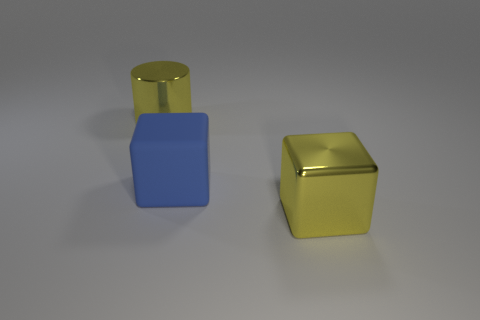Add 1 small green rubber cubes. How many objects exist? 4 Subtract all cylinders. How many objects are left? 2 Add 1 rubber objects. How many rubber objects exist? 2 Subtract 1 yellow cylinders. How many objects are left? 2 Subtract all large yellow objects. Subtract all big blue matte objects. How many objects are left? 0 Add 1 big yellow blocks. How many big yellow blocks are left? 2 